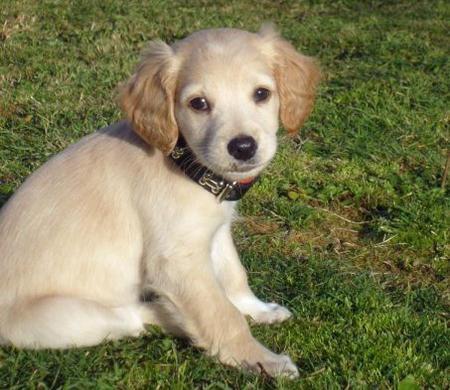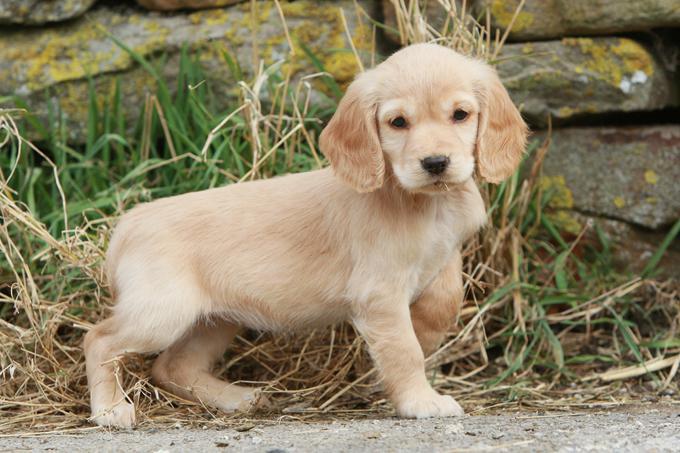The first image is the image on the left, the second image is the image on the right. Given the left and right images, does the statement "There is a fence in the background of one of the images." hold true? Answer yes or no. No. 